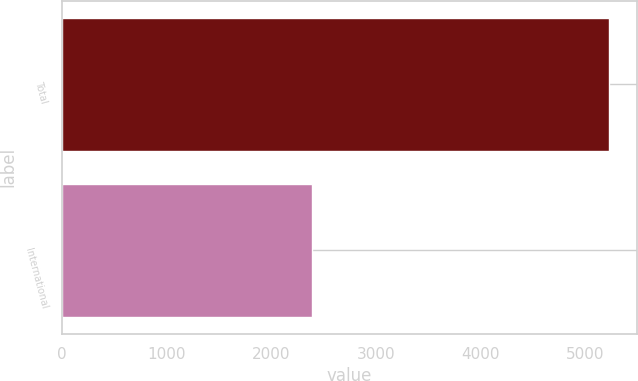<chart> <loc_0><loc_0><loc_500><loc_500><bar_chart><fcel>Total<fcel>International<nl><fcel>5230.6<fcel>2390.6<nl></chart> 